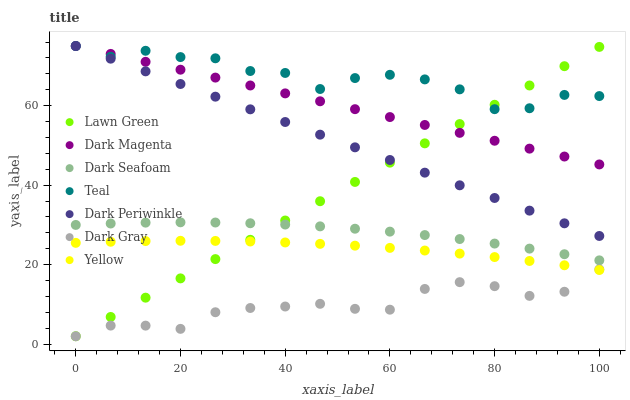Does Dark Gray have the minimum area under the curve?
Answer yes or no. Yes. Does Teal have the maximum area under the curve?
Answer yes or no. Yes. Does Dark Magenta have the minimum area under the curve?
Answer yes or no. No. Does Dark Magenta have the maximum area under the curve?
Answer yes or no. No. Is Lawn Green the smoothest?
Answer yes or no. Yes. Is Teal the roughest?
Answer yes or no. Yes. Is Dark Magenta the smoothest?
Answer yes or no. No. Is Dark Magenta the roughest?
Answer yes or no. No. Does Lawn Green have the lowest value?
Answer yes or no. Yes. Does Dark Magenta have the lowest value?
Answer yes or no. No. Does Dark Periwinkle have the highest value?
Answer yes or no. Yes. Does Yellow have the highest value?
Answer yes or no. No. Is Dark Seafoam less than Dark Magenta?
Answer yes or no. Yes. Is Teal greater than Yellow?
Answer yes or no. Yes. Does Lawn Green intersect Dark Periwinkle?
Answer yes or no. Yes. Is Lawn Green less than Dark Periwinkle?
Answer yes or no. No. Is Lawn Green greater than Dark Periwinkle?
Answer yes or no. No. Does Dark Seafoam intersect Dark Magenta?
Answer yes or no. No. 